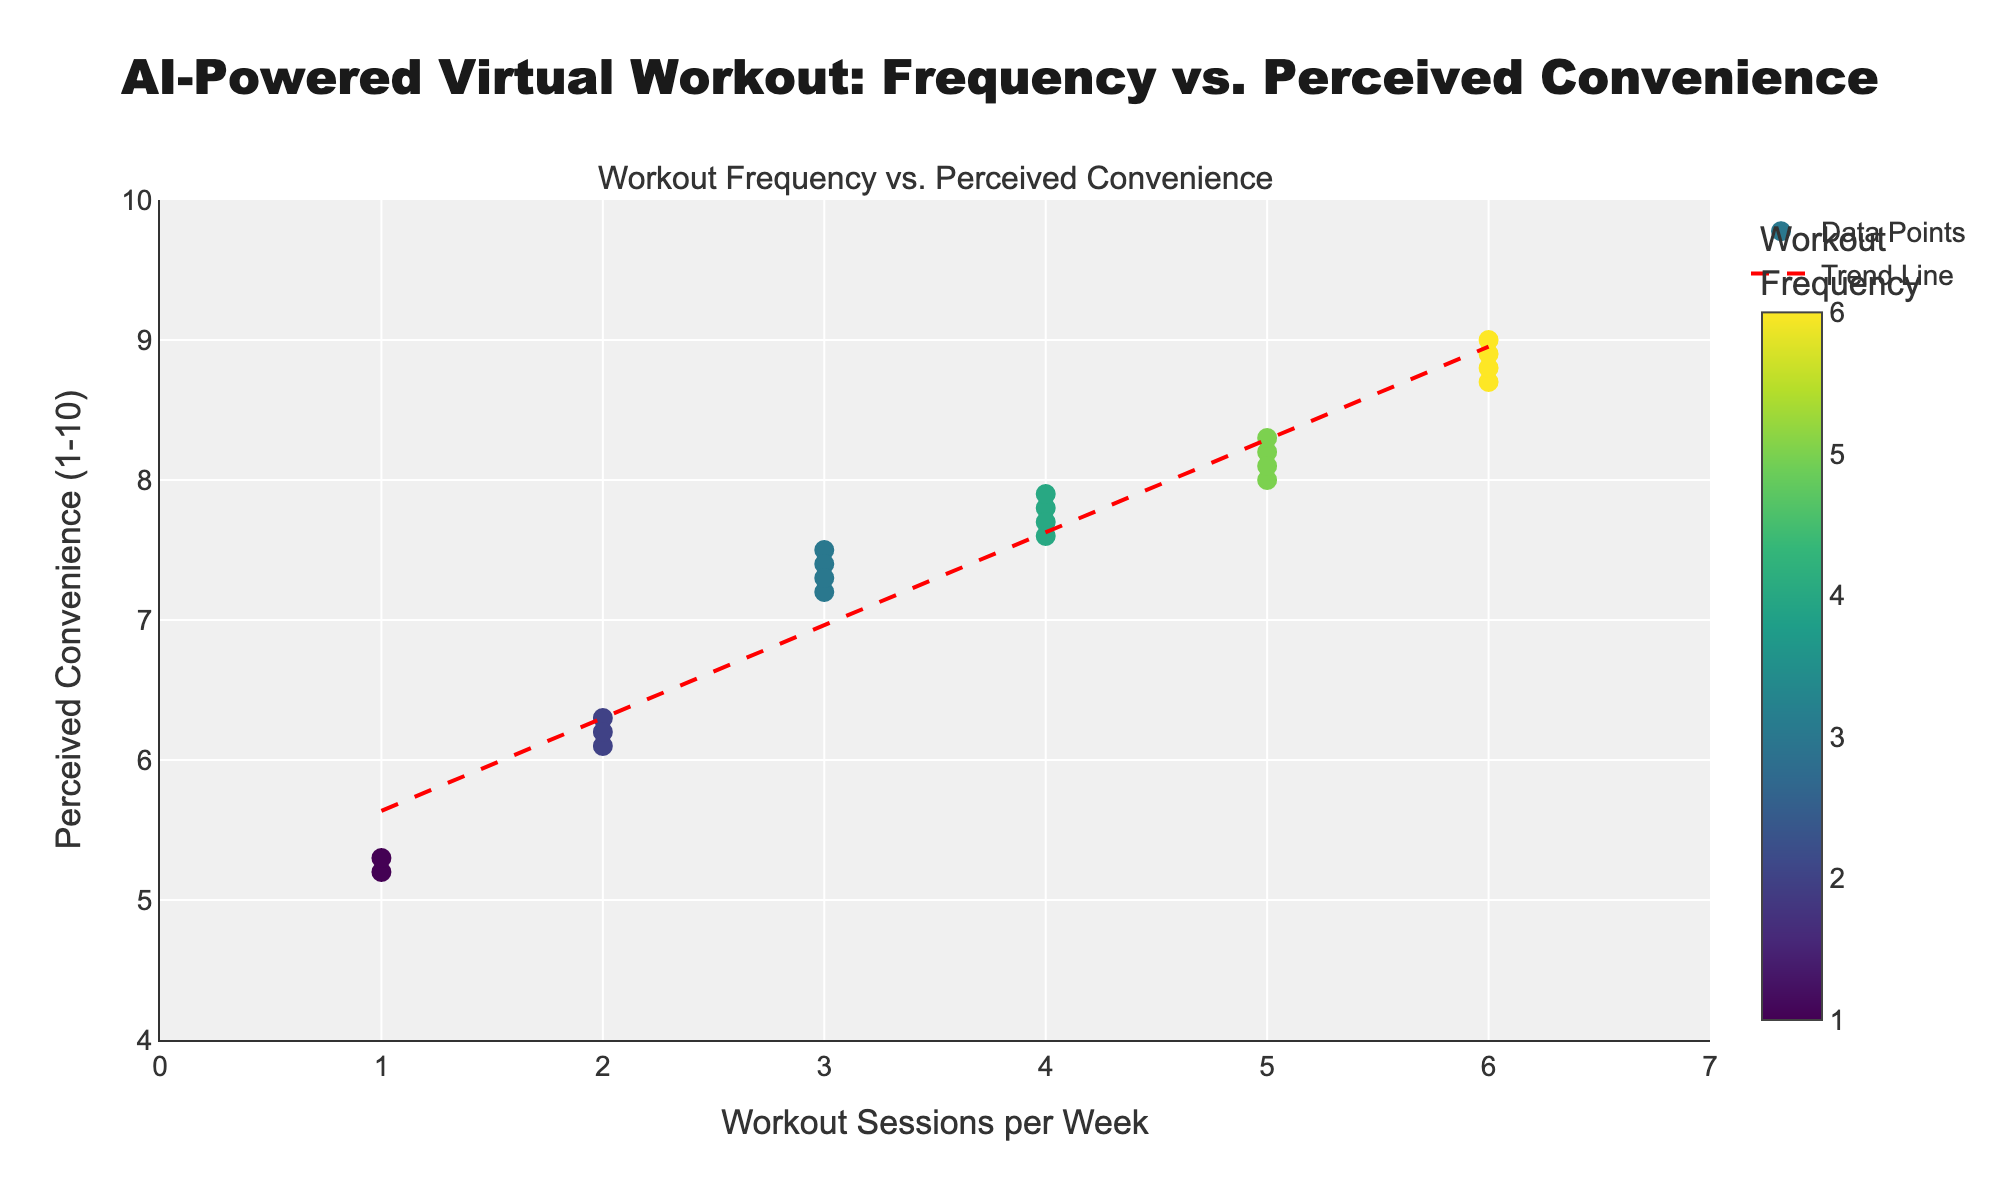What is the title of the plot? The title of the plot is displayed at the top and it reads 'AI-Powered Virtual Workout: Frequency vs. Perceived Convenience'
Answer: AI-Powered Virtual Workout: Frequency vs. Perceived Convenience How many data points are shown in the scatter plot? By counting the markers on the scatter plot, you can determine the number of data points which correspond to the number of users mentioned.
Answer: 20 What are the x-axis and y-axis titles? The x-axis title is located at the bottom of the plot and the y-axis title is on the left side. The x-axis title is 'Workout Sessions per Week' and the y-axis title is 'Perceived Convenience (1-10)'.
Answer: Workout Sessions per Week and Perceived Convenience (1-10) What is the general trend shown by the trend line? The trend line has an upward slope, indicating that as the frequency of workout sessions per week increases, the perceived convenience also tends to increase.
Answer: Increase Which user has the highest frequency of workout sessions per week? By checking the hover text on the scatter plot, the user with the highest frequency can be found. Evan and Uma have the highest frequency, which is 6 sessions per week.
Answer: Evan and Uma Which user perceives the lowest convenience in AI-powered virtual workout solutions? By checking the hover text on the scatter plot for the lowest y-value, you can find that Fay and Quincy perceive the lowest convenience at 5.2 and 5.3, respectively.
Answer: Fay What is the perceived convenience for a frequency of 5 workout sessions per week? By looking at the scatter plot points at x=5 on the x-axis, you can see the perceived convenience values. They are near 8.0 for users like Bob, Hank, Nina, and Tara who have 5 sessions per week.
Answer: Approximately 8.0 Compare the perceived convenience for users with 3 and 6 workout sessions per week. Select points at x=3 and x=6 on the x-axis and compare their y-values (perceived convenience). Users with 3 sessions per week have perceived convenience values around 7.5, while those with 6 sessions per week have values around 8.8.
Answer: Users with 6 sessions per week perceive higher convenience than those with 3 sessions per week What is the slope of the trend line and what does it indicate? The slope of the trend line is found by the linear regression equation fitted to the data points. The positive slope found in the polyfit function indicates that as workout session frequency increases, the perceived convenience also increases.
Answer: Positive slope indicating increase Which frequency of workout sessions per week shows the most variability in perceived convenience? By observing the vertical spread of points at each frequency level on the scatter plot, users with 4 workout sessions per week show a wider range of perceived convenience values from approximately 7.6 to 7.9.
Answer: 4 sessions per week 